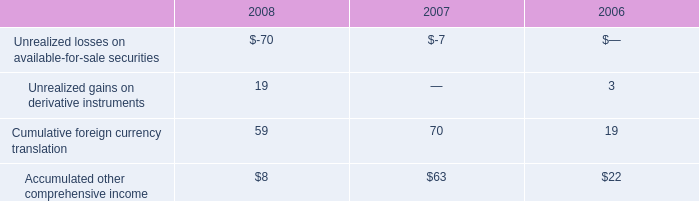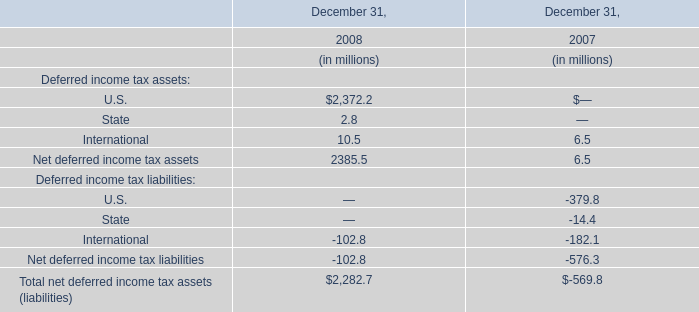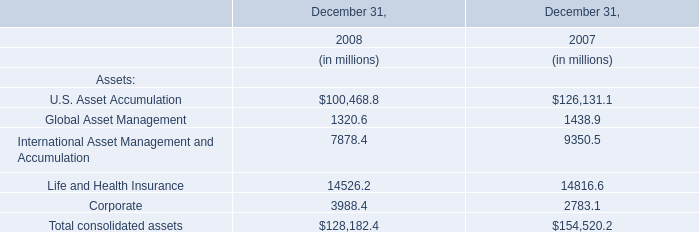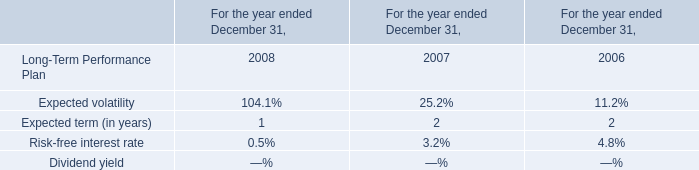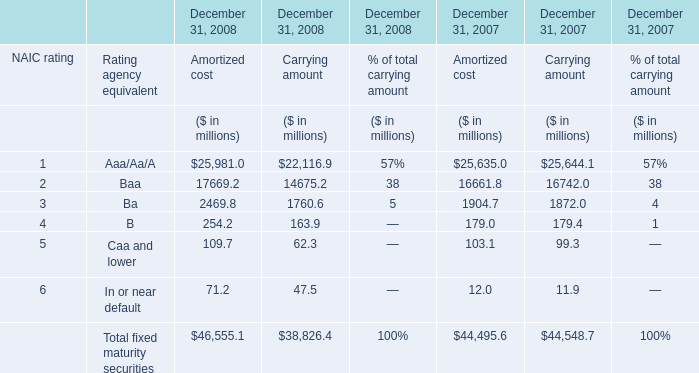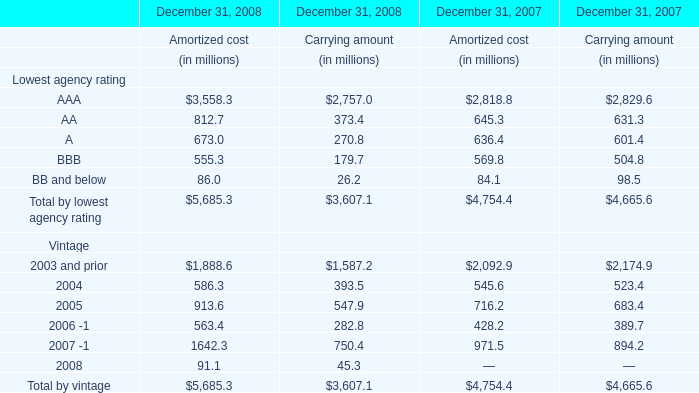What's the sum of AAA of December 31, 2008 Carrying amount, and International Asset Management and Accumulation of December 31, 2007 ? 
Computations: (2757.0 + 9350.5)
Answer: 12107.5. 